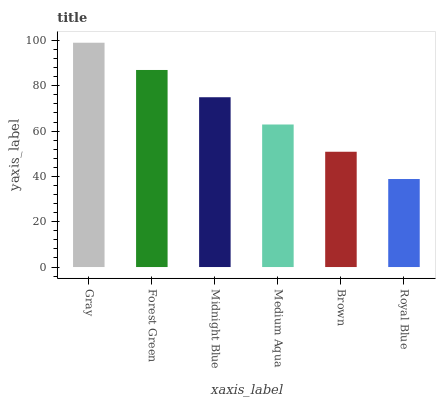Is Royal Blue the minimum?
Answer yes or no. Yes. Is Gray the maximum?
Answer yes or no. Yes. Is Forest Green the minimum?
Answer yes or no. No. Is Forest Green the maximum?
Answer yes or no. No. Is Gray greater than Forest Green?
Answer yes or no. Yes. Is Forest Green less than Gray?
Answer yes or no. Yes. Is Forest Green greater than Gray?
Answer yes or no. No. Is Gray less than Forest Green?
Answer yes or no. No. Is Midnight Blue the high median?
Answer yes or no. Yes. Is Medium Aqua the low median?
Answer yes or no. Yes. Is Royal Blue the high median?
Answer yes or no. No. Is Forest Green the low median?
Answer yes or no. No. 